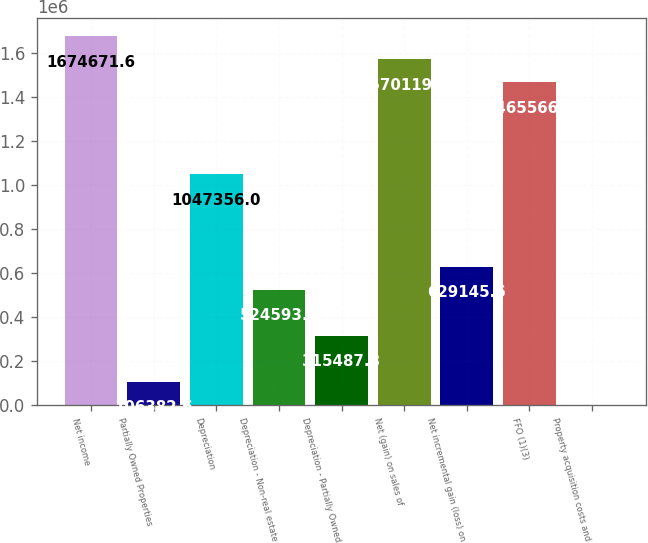Convert chart. <chart><loc_0><loc_0><loc_500><loc_500><bar_chart><fcel>Net income<fcel>Partially Owned Properties<fcel>Depreciation<fcel>Depreciation - Non-real estate<fcel>Depreciation - Partially Owned<fcel>Net (gain) on sales of<fcel>Net incremental gain (loss) on<fcel>FFO (1)(3)<fcel>Property acquisition costs and<nl><fcel>1.67467e+06<fcel>106383<fcel>1.04736e+06<fcel>524593<fcel>315488<fcel>1.57012e+06<fcel>629146<fcel>1.46557e+06<fcel>1830<nl></chart> 